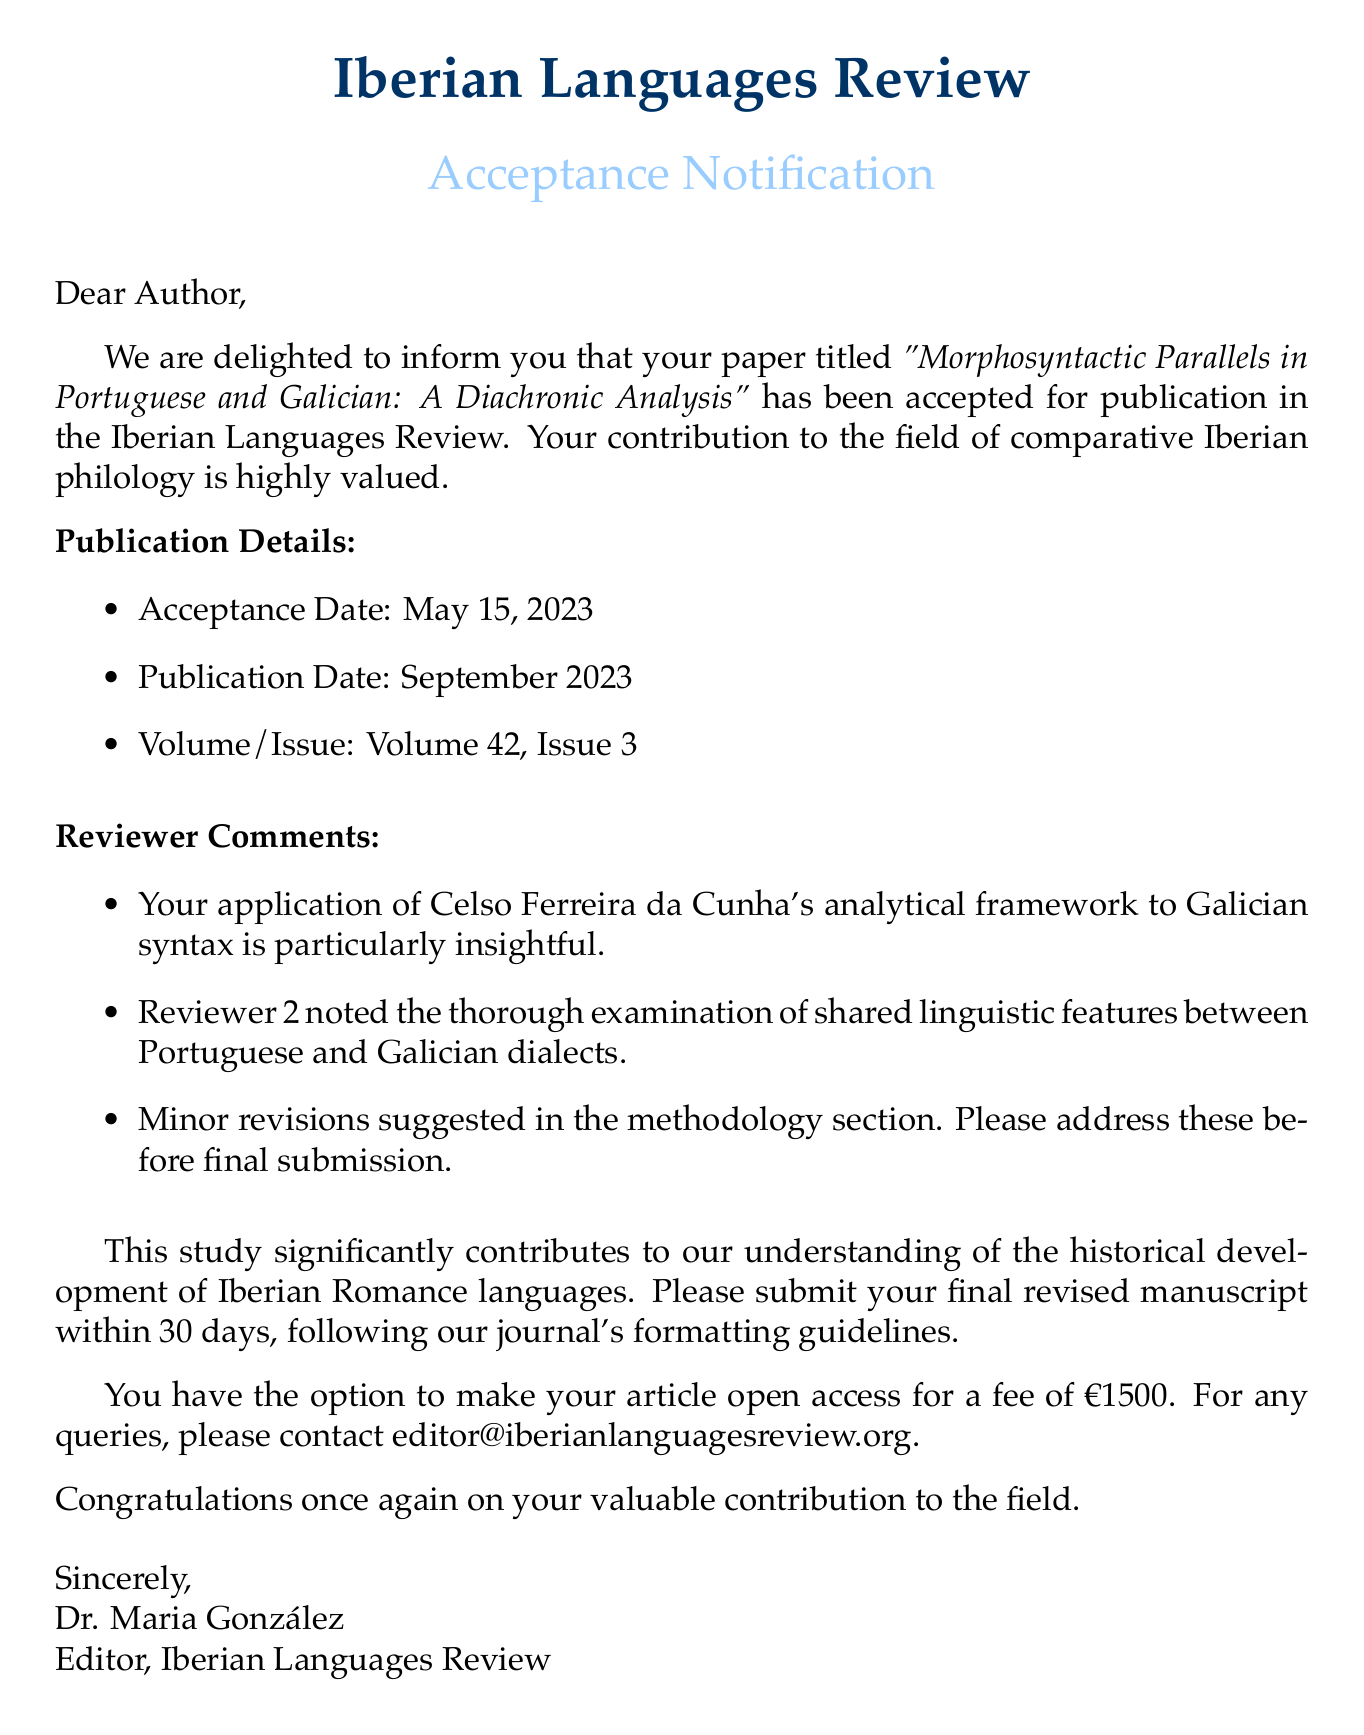What is the name of the journal? The name of the journal is clearly stated at the top of the document, which is the "Iberian Languages Review."
Answer: Iberian Languages Review Who is the editor of the journal? The editor's name is mentioned in the salutation of the email as Dr. Maria González.
Answer: Dr. Maria González What is the acceptance date of the paper? The acceptance date is provided in the publication details section of the document as May 15, 2023.
Answer: May 15, 2023 What notable framework was applied in the paper? The document highlights the application of Celso Ferreira da Cunha's analytical framework, making this a unique aspect of the research discussed.
Answer: Celso Ferreira da Cunha's analytical framework What are the minor revisions suggested in the paper? The specific section that requires revisions is identified as the methodology section in the reviewer comments.
Answer: Methodology section What is the publication date of the paper? The publication date is provided in the publication details section as September 2023.
Answer: September 2023 What is the fee for making the article open access? The document notes that there is an option to make the article open access for a fee, which is explicitly stated as €1500.
Answer: €1500 How long does the author have to submit the final revised manuscript? The document specifies that the author must submit the final revised manuscript within 30 days.
Answer: 30 days 